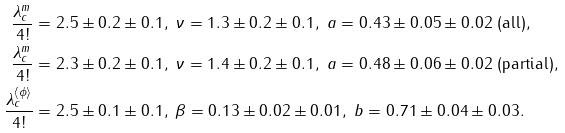Convert formula to latex. <formula><loc_0><loc_0><loc_500><loc_500>\frac { \lambda _ { c } ^ { m } } { 4 ! } & = 2 . 5 \pm 0 . 2 \pm 0 . 1 , \ \nu = 1 . 3 \pm 0 . 2 \pm 0 . 1 , \ a = 0 . 4 3 \pm 0 . 0 5 \pm 0 . 0 2 \text { (all)} , \\ \frac { \lambda _ { c } ^ { m } } { 4 ! } & = 2 . 3 \pm 0 . 2 \pm 0 . 1 , \ \nu = 1 . 4 \pm 0 . 2 \pm 0 . 1 , \ a = 0 . 4 8 \pm 0 . 0 6 \pm 0 . 0 2 \text { (partial)} , \\ \ \frac { \lambda _ { c } ^ { \left \langle \phi \right \rangle } } { 4 ! } & = 2 . 5 \pm 0 . 1 \pm 0 . 1 , \ \beta = 0 . 1 3 \pm 0 . 0 2 \pm 0 . 0 1 , \ b = 0 . 7 1 \pm 0 . 0 4 \pm 0 . 0 3 .</formula> 